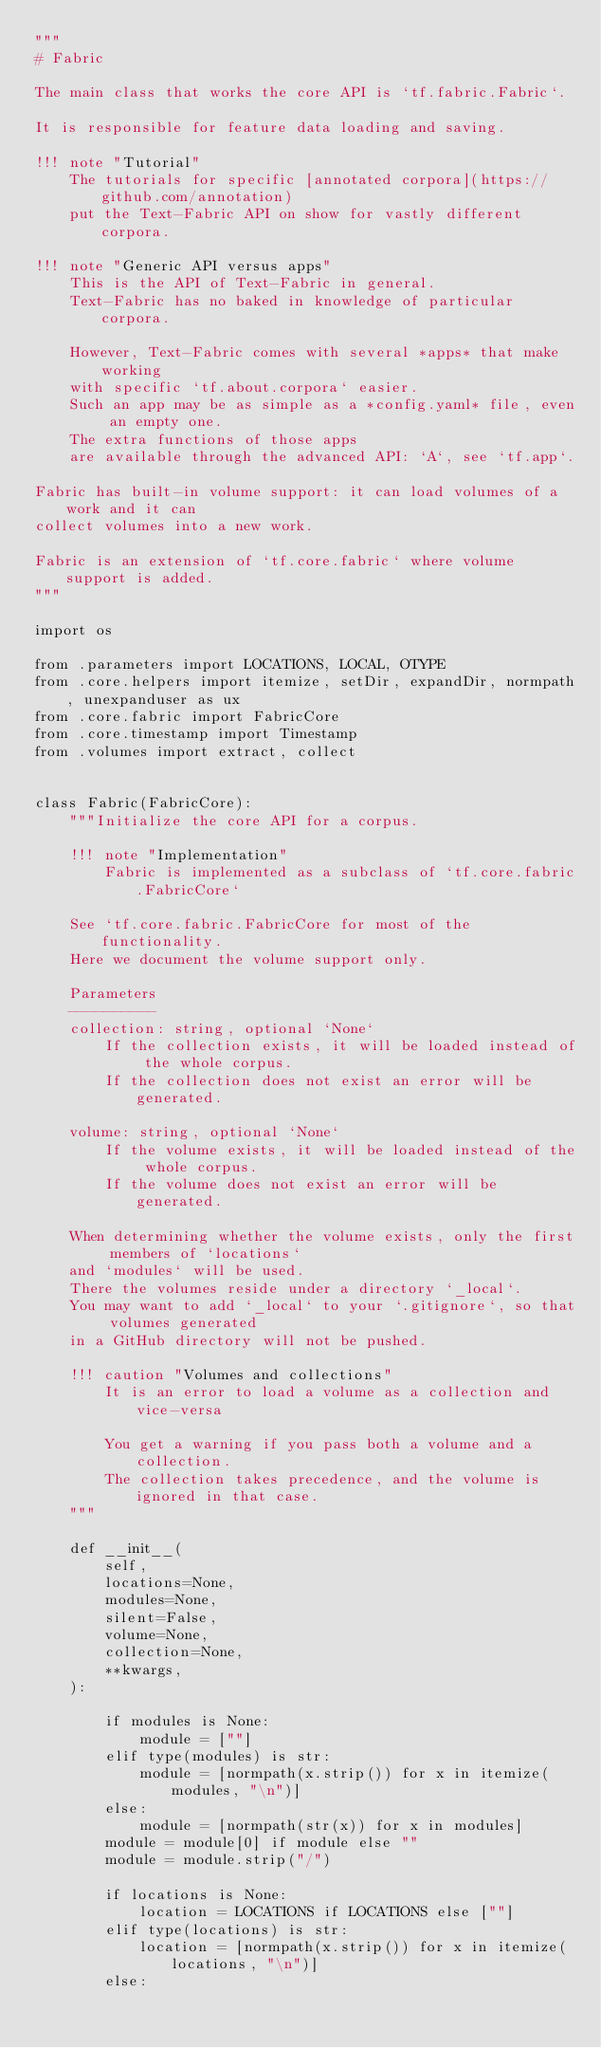Convert code to text. <code><loc_0><loc_0><loc_500><loc_500><_Python_>"""
# Fabric

The main class that works the core API is `tf.fabric.Fabric`.

It is responsible for feature data loading and saving.

!!! note "Tutorial"
    The tutorials for specific [annotated corpora](https://github.com/annotation)
    put the Text-Fabric API on show for vastly different corpora.

!!! note "Generic API versus apps"
    This is the API of Text-Fabric in general.
    Text-Fabric has no baked in knowledge of particular corpora.

    However, Text-Fabric comes with several *apps* that make working
    with specific `tf.about.corpora` easier.
    Such an app may be as simple as a *config.yaml* file, even an empty one.
    The extra functions of those apps
    are available through the advanced API: `A`, see `tf.app`.

Fabric has built-in volume support: it can load volumes of a work and it can
collect volumes into a new work.

Fabric is an extension of `tf.core.fabric` where volume support is added.
"""

import os

from .parameters import LOCATIONS, LOCAL, OTYPE
from .core.helpers import itemize, setDir, expandDir, normpath, unexpanduser as ux
from .core.fabric import FabricCore
from .core.timestamp import Timestamp
from .volumes import extract, collect


class Fabric(FabricCore):
    """Initialize the core API for a corpus.

    !!! note "Implementation"
        Fabric is implemented as a subclass of `tf.core.fabric.FabricCore`

    See `tf.core.fabric.FabricCore for most of the functionality.
    Here we document the volume support only.

    Parameters
    ----------
    collection: string, optional `None`
        If the collection exists, it will be loaded instead of the whole corpus.
        If the collection does not exist an error will be generated.

    volume: string, optional `None`
        If the volume exists, it will be loaded instead of the whole corpus.
        If the volume does not exist an error will be generated.

    When determining whether the volume exists, only the first members of `locations`
    and `modules` will be used.
    There the volumes reside under a directory `_local`.
    You may want to add `_local` to your `.gitignore`, so that volumes generated
    in a GitHub directory will not be pushed.

    !!! caution "Volumes and collections"
        It is an error to load a volume as a collection and vice-versa

        You get a warning if you pass both a volume and a collection.
        The collection takes precedence, and the volume is ignored in that case.
    """

    def __init__(
        self,
        locations=None,
        modules=None,
        silent=False,
        volume=None,
        collection=None,
        **kwargs,
    ):

        if modules is None:
            module = [""]
        elif type(modules) is str:
            module = [normpath(x.strip()) for x in itemize(modules, "\n")]
        else:
            module = [normpath(str(x)) for x in modules]
        module = module[0] if module else ""
        module = module.strip("/")

        if locations is None:
            location = LOCATIONS if LOCATIONS else [""]
        elif type(locations) is str:
            location = [normpath(x.strip()) for x in itemize(locations, "\n")]
        else:</code> 